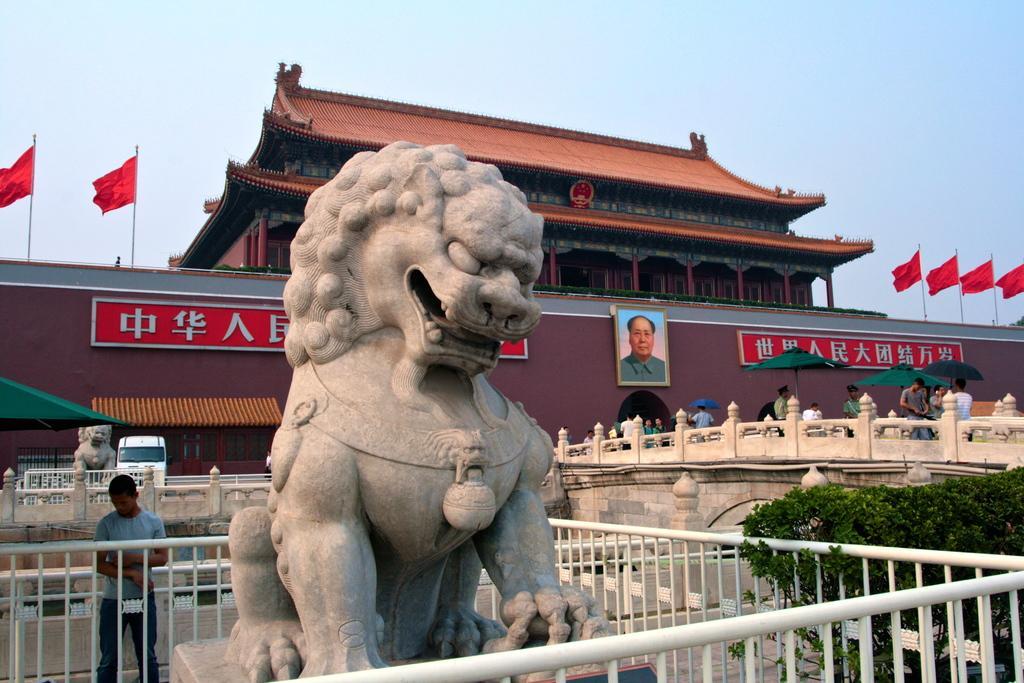Could you give a brief overview of what you see in this image? In this image we can see a sculpture and fencing. Behind the sculpture we can see a building. On the building we can see text, flags and a photo of a person. On the right side, we can see a bridge and on the bridge we can see many persons and umbrellas. In the bottom right we can see few plants. On the left side, we can see a vehicle, person and a sculpture. At the top we can see the sky. 